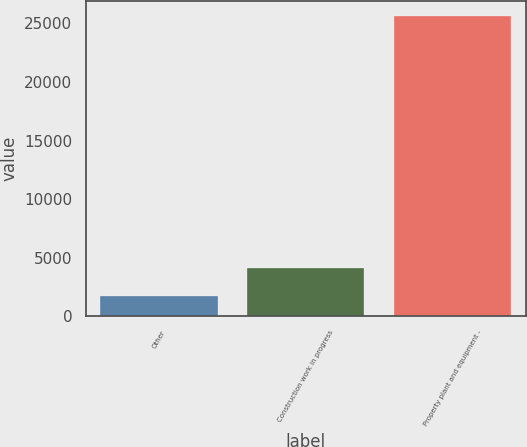<chart> <loc_0><loc_0><loc_500><loc_500><bar_chart><fcel>Other<fcel>Construction work in progress<fcel>Property plant and equipment -<nl><fcel>1716<fcel>4105.3<fcel>25609<nl></chart> 